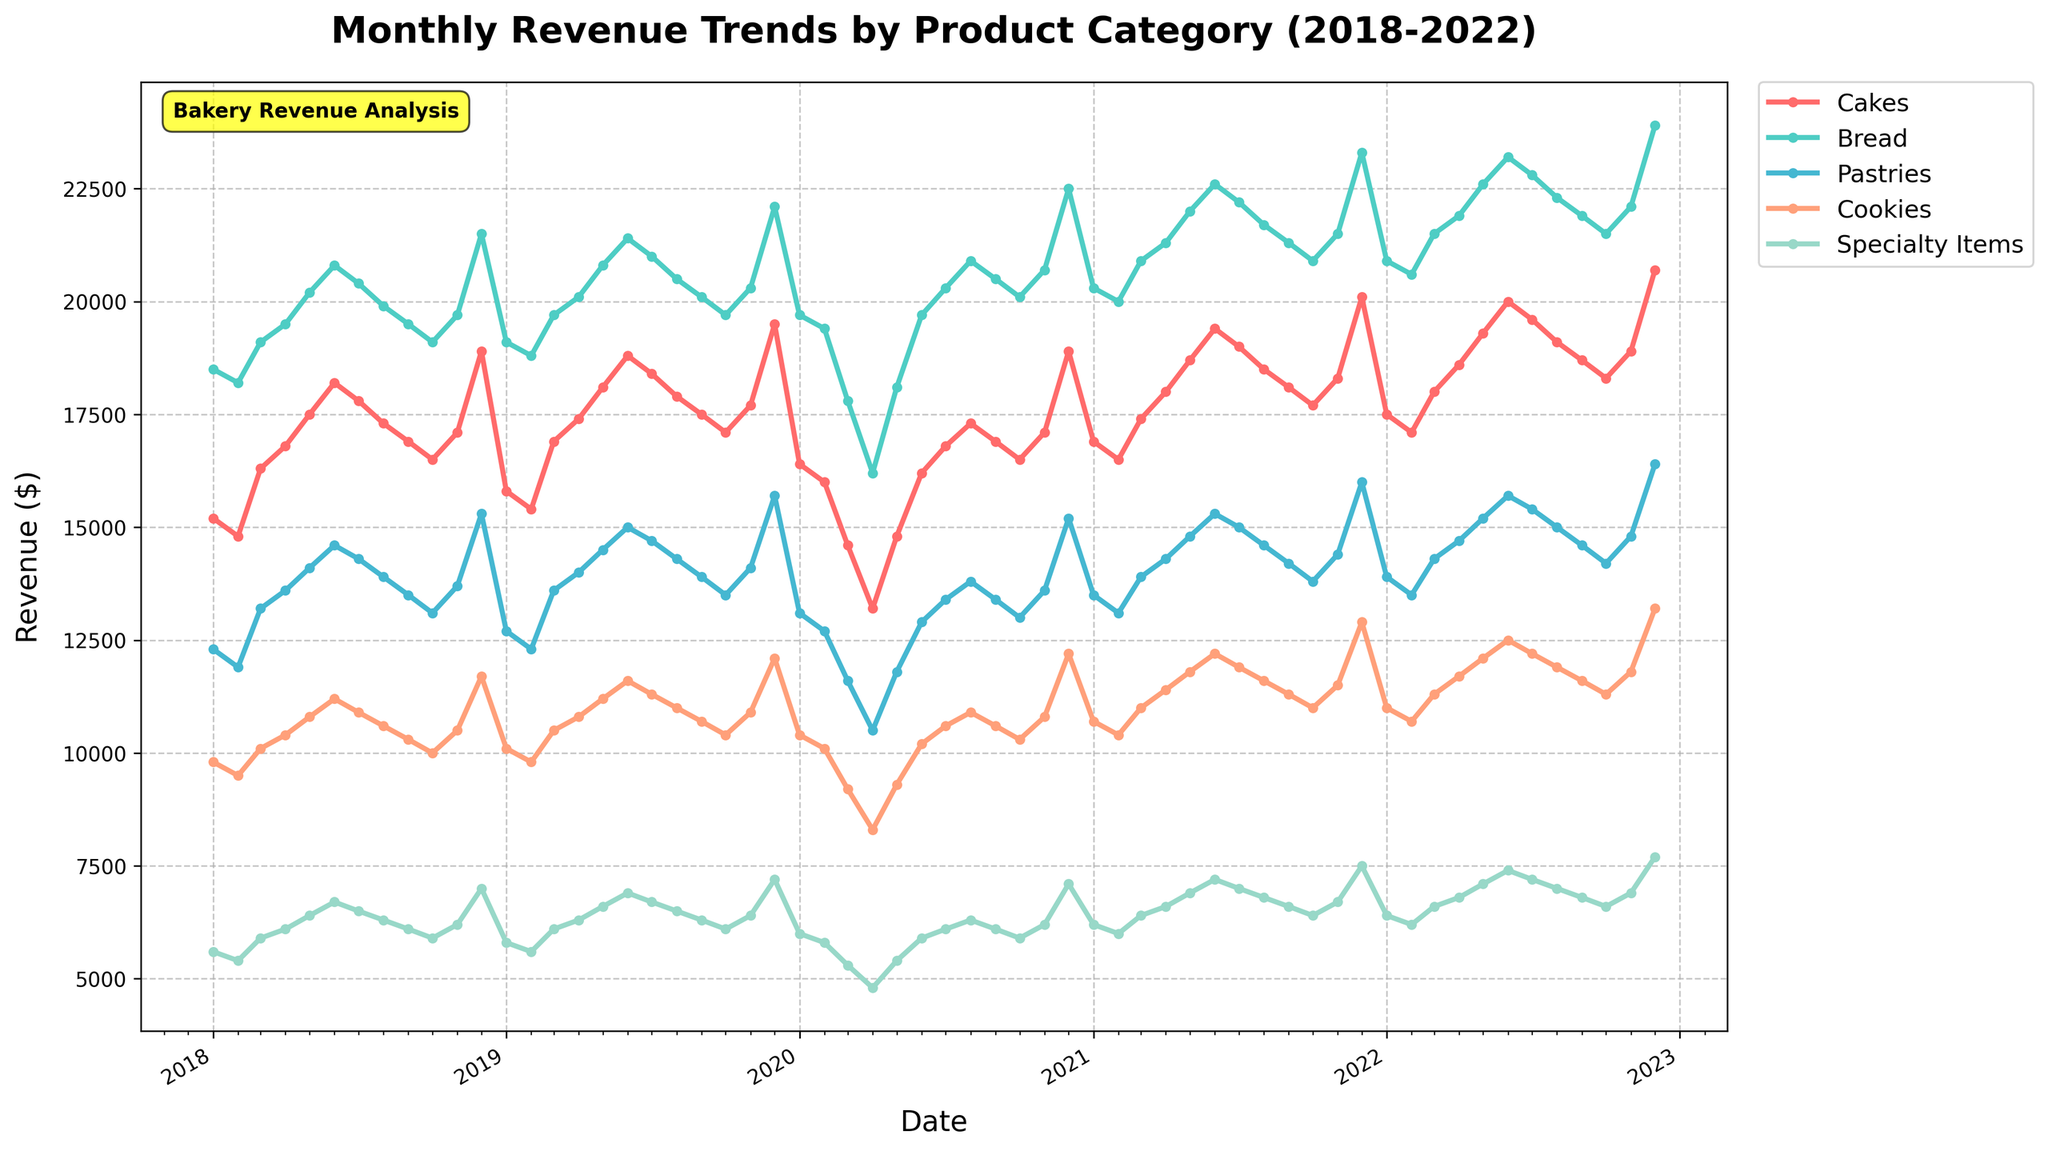What are the overall revenue trends for the "Cakes" and "Pastries" categories from 2018 to 2022? To determine the trends, observe the lines representing "Cakes" and "Pastries." For "Cakes," the trend begins at around $15,200 in Jan 2018 and increases to $20,700 in Dec 2022. For "Pastries," the trend starts at around $12,300 in Jan 2018 and increases to $16,400 by Dec 2022.
Answer: Upward trends for both categories Which product category showed the largest increase in revenue in December over the years 2018 to 2022? Compare the revenue growth for all categories in the month of December for each year. "Cakes" increased from $18,900 in Dec 2018 to $20,700 in Dec 2022, while "Specialty Items" increased from $7,000 to $7,700 in the same period. "Bread" increased the most, from $21,500 to $23,900.
Answer: Bread In which month and year did the "Cookies" category experience the lowest revenue? Look at the data points for the "Cookies" category across all months and years. The lowest revenue for "Cookies" is around $8,300 in April 2020.
Answer: April 2020 Compare the revenue of "Specialty Items" in December 2018 and December 2020. What is the difference? Find and subtract the revenue of "Specialty Items" in Dec 2018 ($7,000) and in Dec 2020 ($7,100). The difference is $7,100 - $7,000.
Answer: $100 By how much did the revenue of the "Bread" category decrease from February 2020 to April 2020? Locate the revenues for "Bread" in February 2020 ($19,400) and April 2020 ($16,200). Calculate the decrease by subtracting April from February: $19,400 - $16,200.
Answer: $3,200 Which category had the most consistent revenue between 2018 and 2022? Examine the smoothness and consistency of the lines for each category. "Bread" shows a steady increase without major fluctuations compared to others.
Answer: Bread What was the average monthly revenue for "Cakes" in the year 2022? Sum the revenues for "Cakes" from Jan 2022 to Dec 2022 and divide by 12. The sum is $224,800 and the average is $224,800 / 12.
Answer: $18,733.33 Did any category have lower revenue in any month of 2022 compared to the same month in 2021? Compare month-by-month revenues for each category between 2021 and 2022. "Bread" had lower revenue in Jan 2022 ($20,900) compared to Jan 2021 ($20,300).
Answer: Yes How did revenues for "Specialty Items" perform during the COVID-19 period (March 2020 to December 2020)? Observe the line for "Specialty Items" from March 2020 ($5,300) to December 2020 ($7,100). The revenue trend initially decreases but recovers towards the end of the year.
Answer: Drops and then recovers 